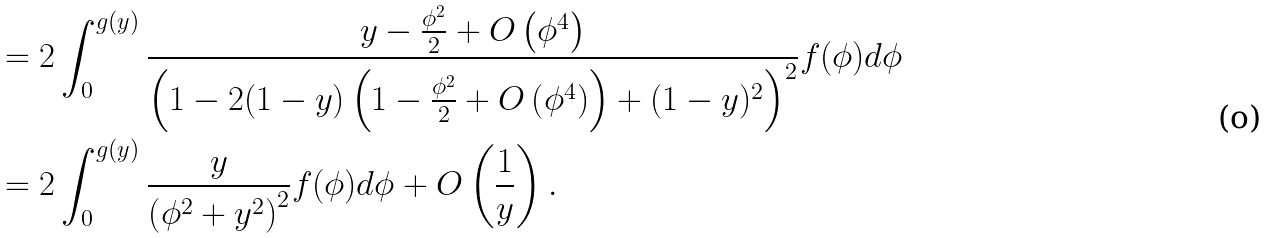<formula> <loc_0><loc_0><loc_500><loc_500>& = 2 \int _ { 0 } ^ { g ( y ) } \frac { y - \frac { \phi ^ { 2 } } { 2 } + O \left ( \phi ^ { 4 } \right ) } { \left ( 1 - 2 ( 1 - y ) \left ( 1 - \frac { \phi ^ { 2 } } { 2 } + O \left ( \phi ^ { 4 } \right ) \right ) + ( 1 - y ) ^ { 2 } \right ) ^ { 2 } } f ( \phi ) d \phi \\ & = 2 \int _ { 0 } ^ { g ( y ) } \frac { y } { \left ( \phi ^ { 2 } + y ^ { 2 } \right ) ^ { 2 } } f ( \phi ) d \phi + O \left ( \frac { 1 } { y } \right ) . \\</formula> 